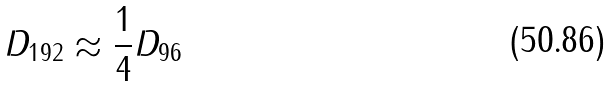<formula> <loc_0><loc_0><loc_500><loc_500>D _ { 1 9 2 } \approx \frac { 1 } { 4 } D _ { 9 6 }</formula> 